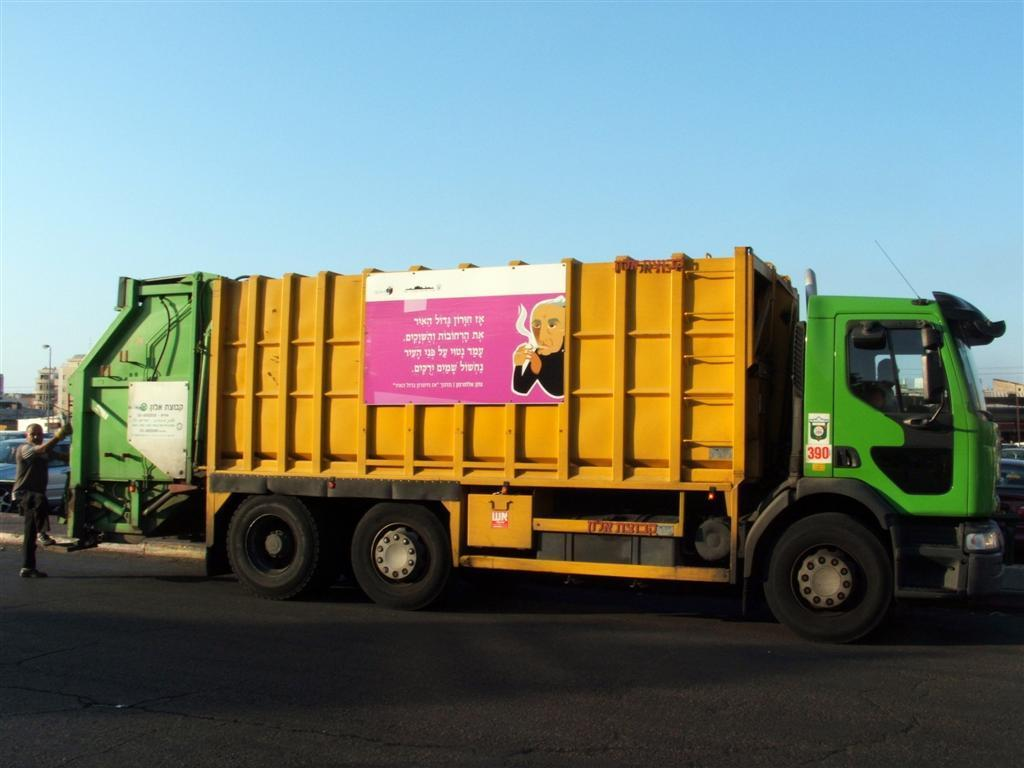What is the main subject in the center of the image? There is a truck in the center of the image. Where is the truck located? The truck is on the road. What can be seen on the left side of the image? There is a person standing at a desk on the left side of the image. What is visible in the background of the image? There are buildings, a pole, and the sky visible in the background of the image. What type of animal is the doctor treating in the image? There is no animal or doctor present in the image. Who is the owner of the truck in the image? The image does not provide information about the ownership of the truck. 